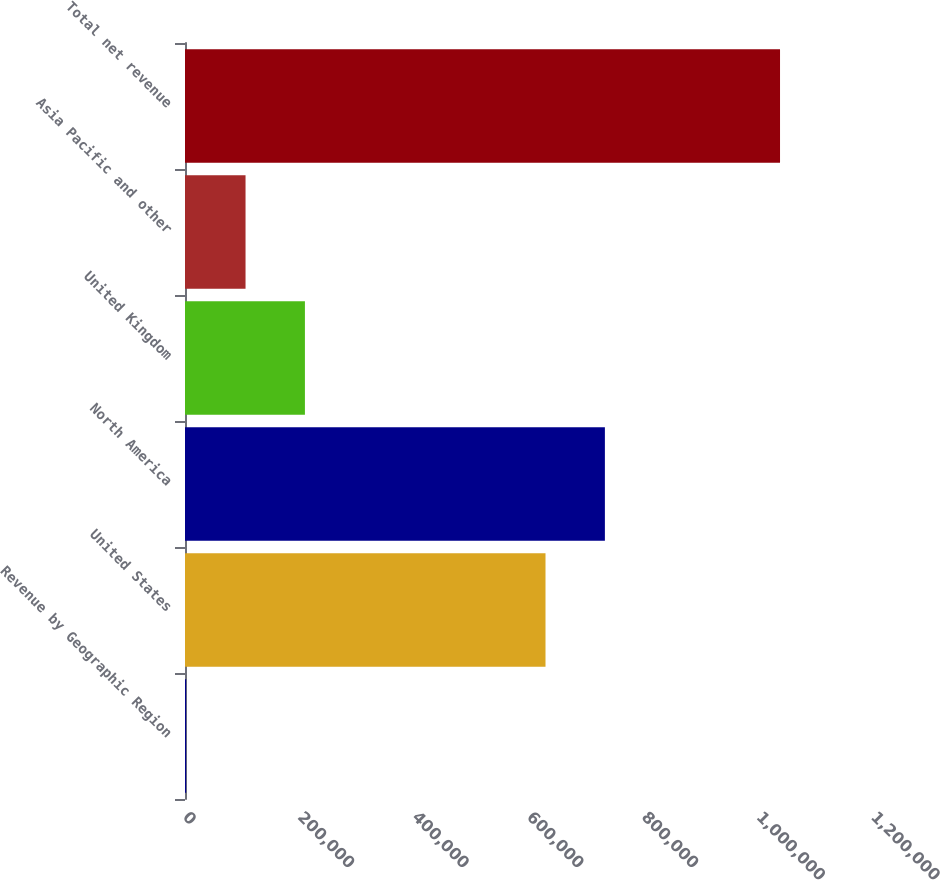<chart> <loc_0><loc_0><loc_500><loc_500><bar_chart><fcel>Revenue by Geographic Region<fcel>United States<fcel>North America<fcel>United Kingdom<fcel>Asia Pacific and other<fcel>Total net revenue<nl><fcel>2006<fcel>628785<fcel>732368<fcel>209173<fcel>105589<fcel>1.03784e+06<nl></chart> 